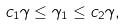<formula> <loc_0><loc_0><loc_500><loc_500>c _ { 1 } \gamma \leq \gamma _ { 1 } \leq c _ { 2 } \gamma ,</formula> 